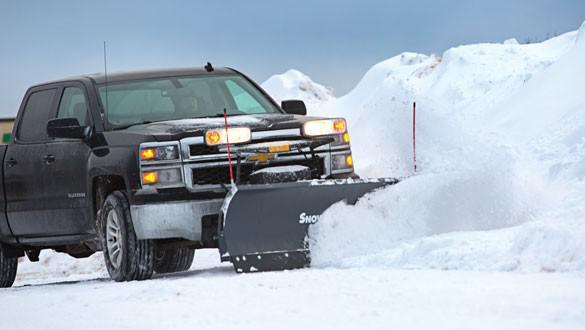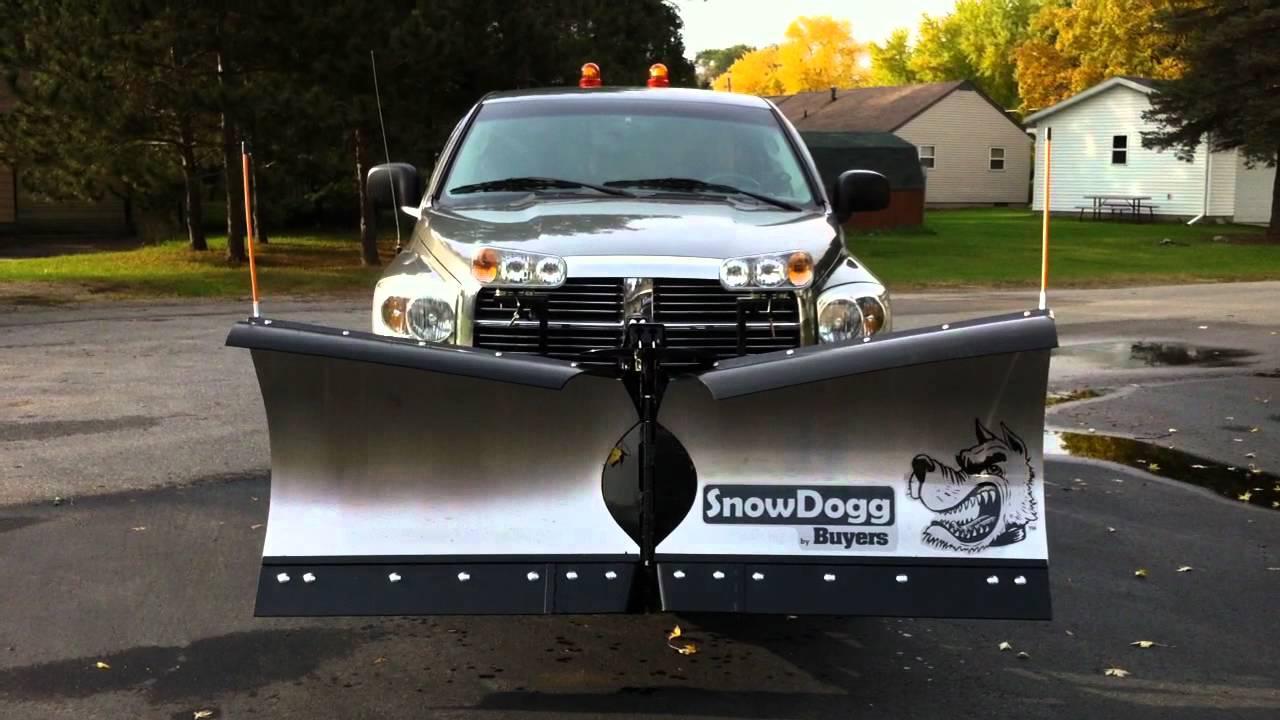The first image is the image on the left, the second image is the image on the right. Examine the images to the left and right. Is the description "A truck is red." accurate? Answer yes or no. No. The first image is the image on the left, the second image is the image on the right. Analyze the images presented: Is the assertion "At least one of the plows is made up of two separate panels with a gap between them." valid? Answer yes or no. Yes. 